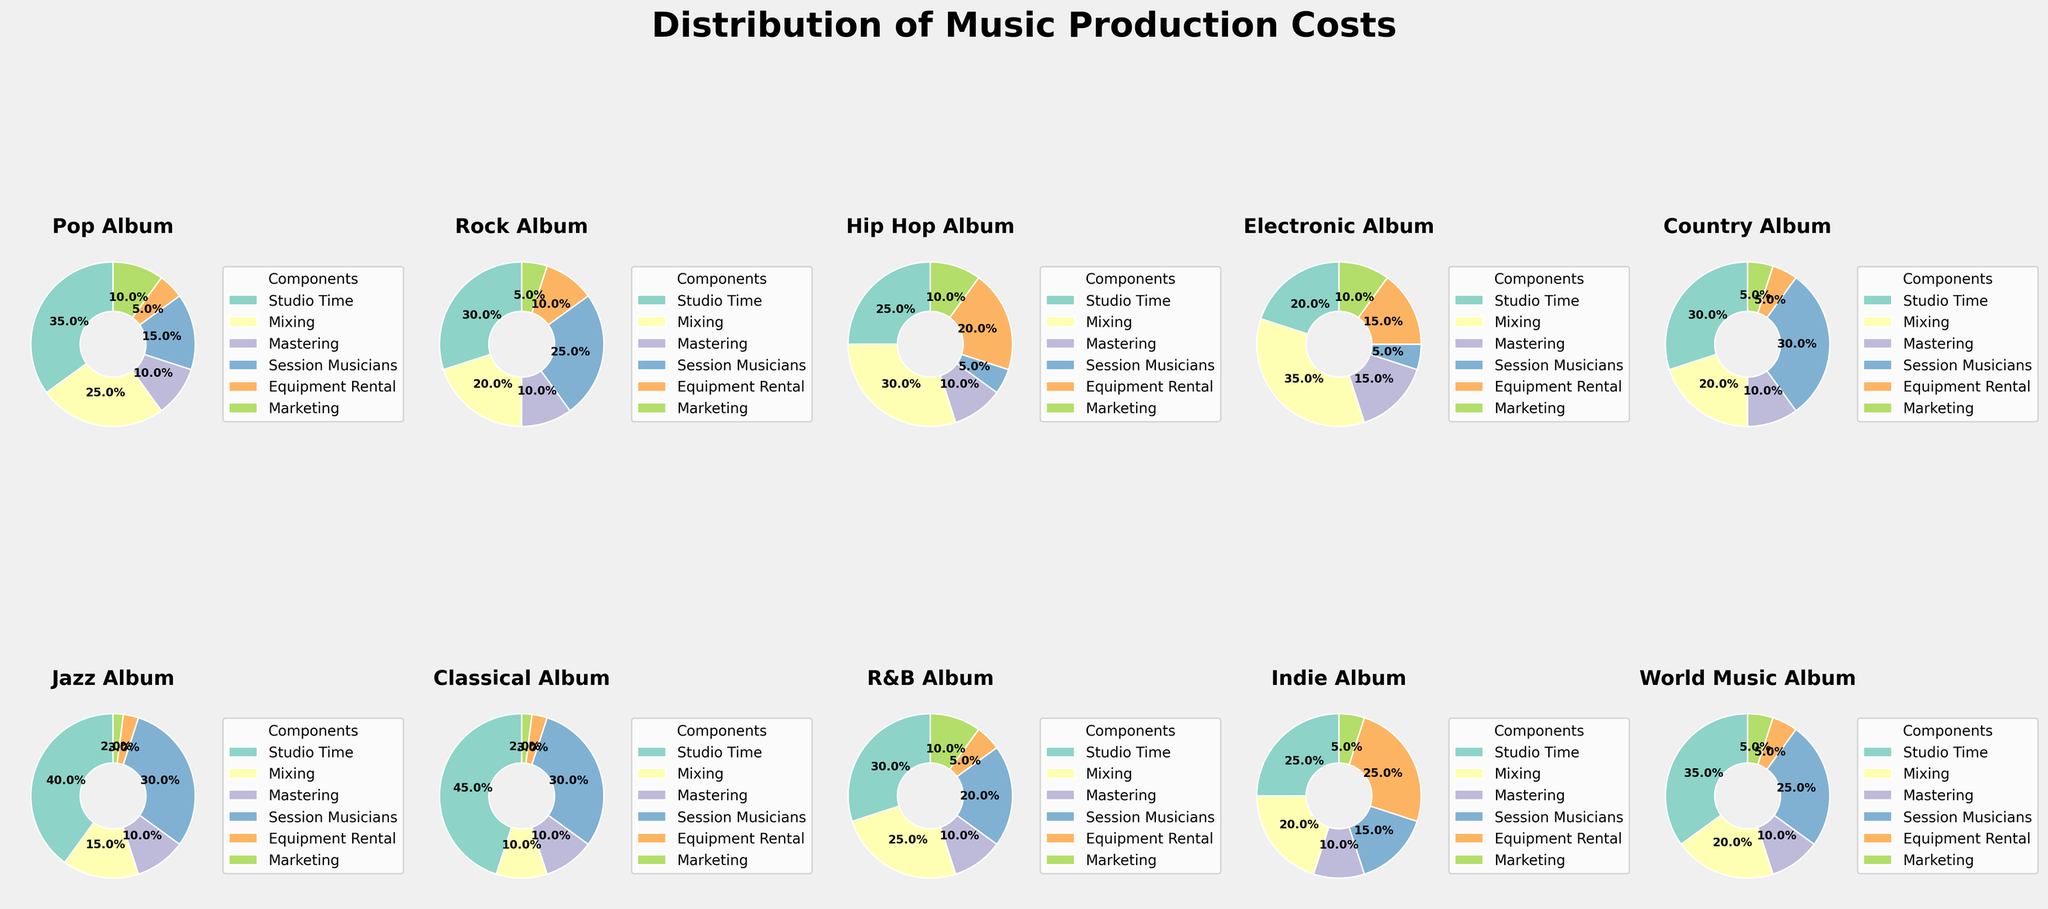Which album component has the largest proportion of production costs in the Pop Album? By looking at the Pop Album pie chart, the largest segment represents the highest cost.
Answer: Studio Time Which album allocates the highest percentage of its budget to Mixing? By examining the pie charts for all albums, we find the album with the largest Mixing segment. The Hip Hop Album has the largest Mixing segment.
Answer: Hip Hop Album What is the combined percentage of Studio Time and Marketing costs in the Rock Album? Find the segments for Studio Time and Marketing in the Rock Album pie chart and add them: 30% + 5% = 35%
Answer: 35% Compare the proportion of Equipment Rental costs between the Indie Album and the Hip Hop Album. Which one has a higher percentage? Look at the Equipment Rental segments in both the Indie Album and Hip Hop Album pie charts. The Indie Album has a higher segment.
Answer: Indie Album Which two album components together make up approximately half of the Jazz Album's production costs? Identify two segments in the Jazz Album pie chart that add up to around 50%. Studio Time and Session Musicians each account for 40% and 30%, respectively, totaling 70%, which is close to half when considering a 50/50 split balance.
Answer: Studio Time and Session Musicians What is the least funded component in the Classical Album? Look at the Classical Album pie chart and identify the smallest segment, which represents the least funded component.
Answer: Marketing Which album allocates the highest percentage of its budget to Session Musicians? By viewing the pie charts for all albums, find the one with the largest segment for Session Musicians. The Classical Album has the largest Session Musicians segment.
Answer: Classical Album How do the Marketing costs of the R&B Album compare with those of the Country Album? Examine the Marketing segments in both the R&B Album and Country Album pie charts. The R&B Album has a higher percentage for this component.
Answer: R&B Album What is the average percentage spent on Mastering across all albums? Calculate the average by summing the Mastering percentages of each album and dividing by the number of albums: (10+10+10+15+10+10+10+10+10+10)/10 = 10.5%
Answer: 10.5% Which album has the closest to an equal distribution of costs across all components? Check all the albums' pie charts and find the one where the segments look relatively equal in size. The World Music Album is the closest to having an equal distribution.
Answer: World Music Album 